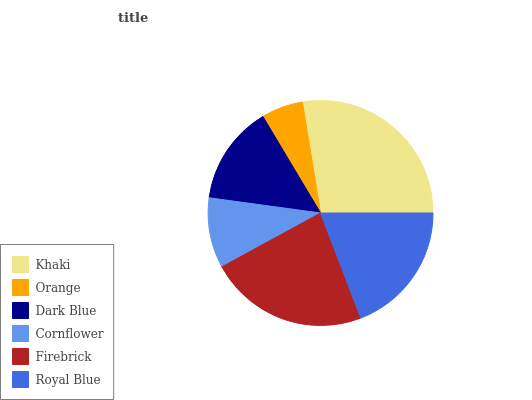Is Orange the minimum?
Answer yes or no. Yes. Is Khaki the maximum?
Answer yes or no. Yes. Is Dark Blue the minimum?
Answer yes or no. No. Is Dark Blue the maximum?
Answer yes or no. No. Is Dark Blue greater than Orange?
Answer yes or no. Yes. Is Orange less than Dark Blue?
Answer yes or no. Yes. Is Orange greater than Dark Blue?
Answer yes or no. No. Is Dark Blue less than Orange?
Answer yes or no. No. Is Royal Blue the high median?
Answer yes or no. Yes. Is Dark Blue the low median?
Answer yes or no. Yes. Is Dark Blue the high median?
Answer yes or no. No. Is Firebrick the low median?
Answer yes or no. No. 